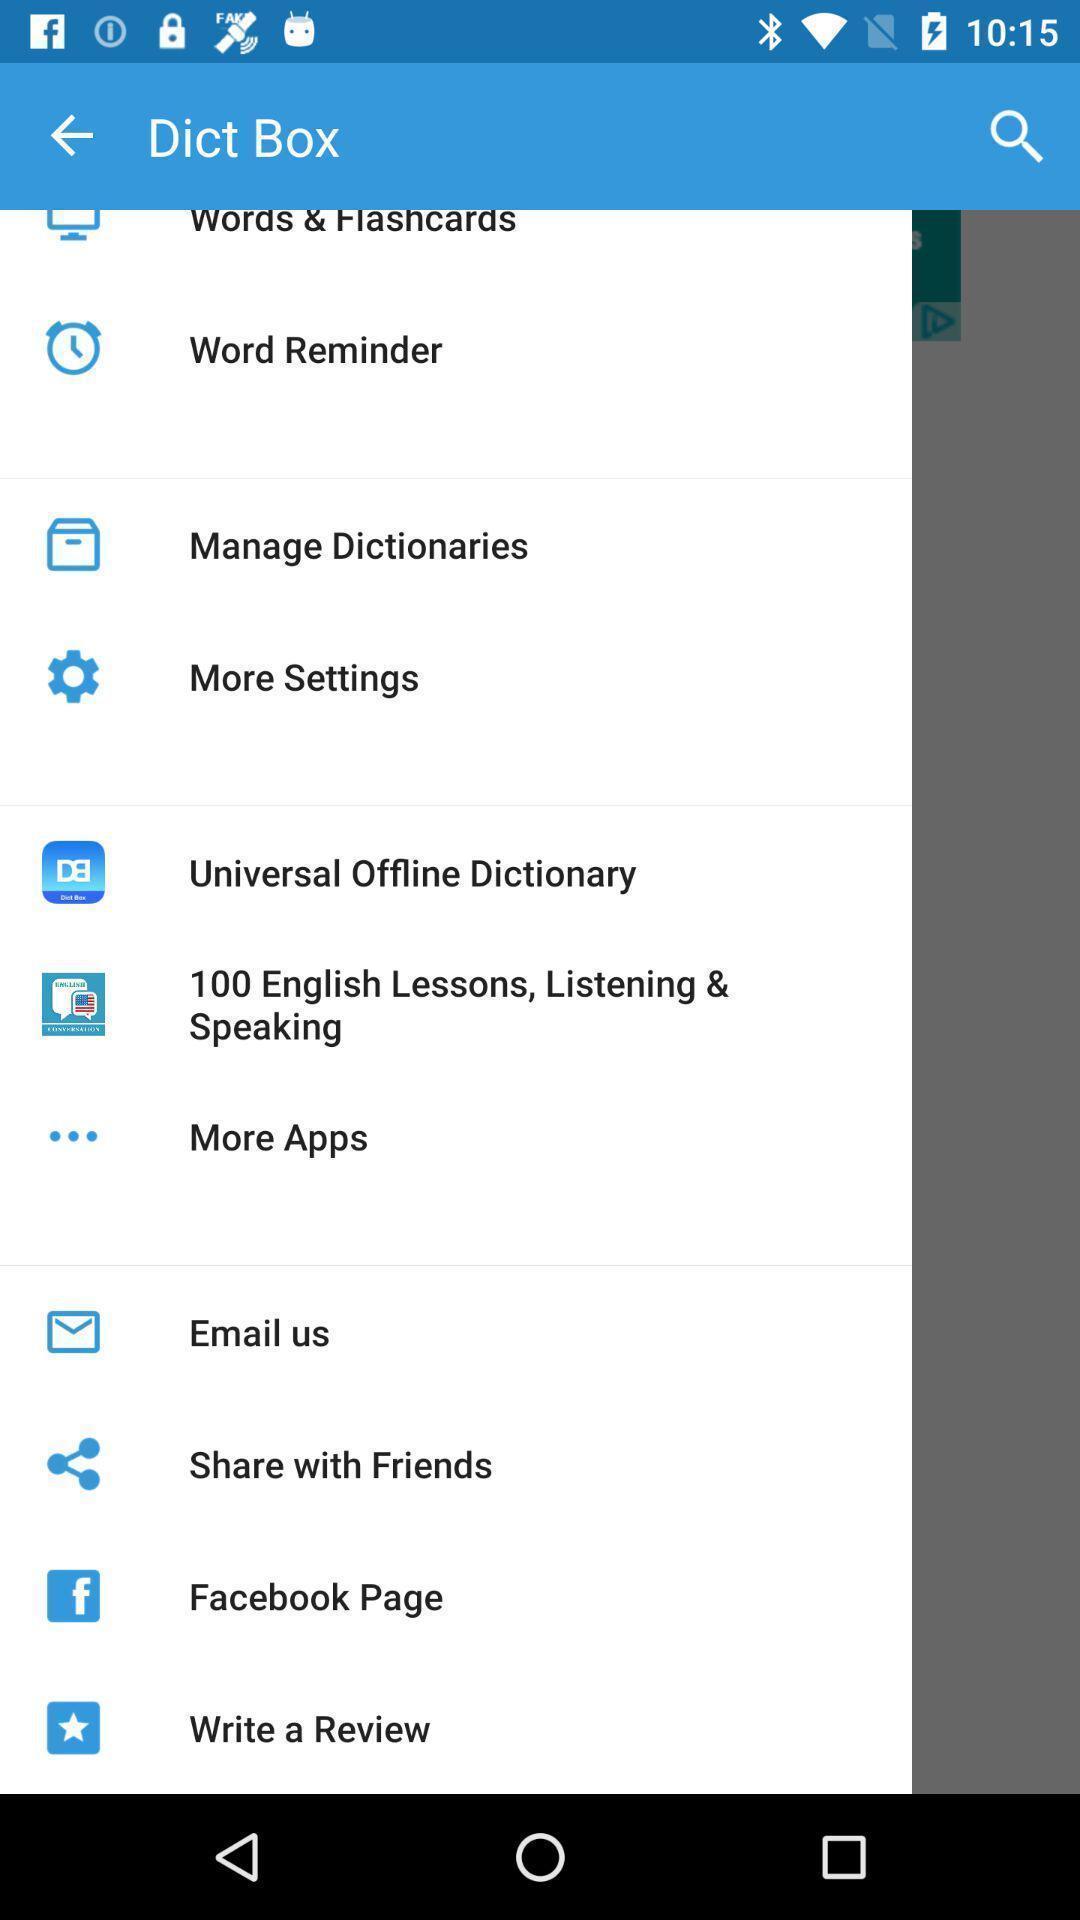Give me a summary of this screen capture. Pop up list of different options. 